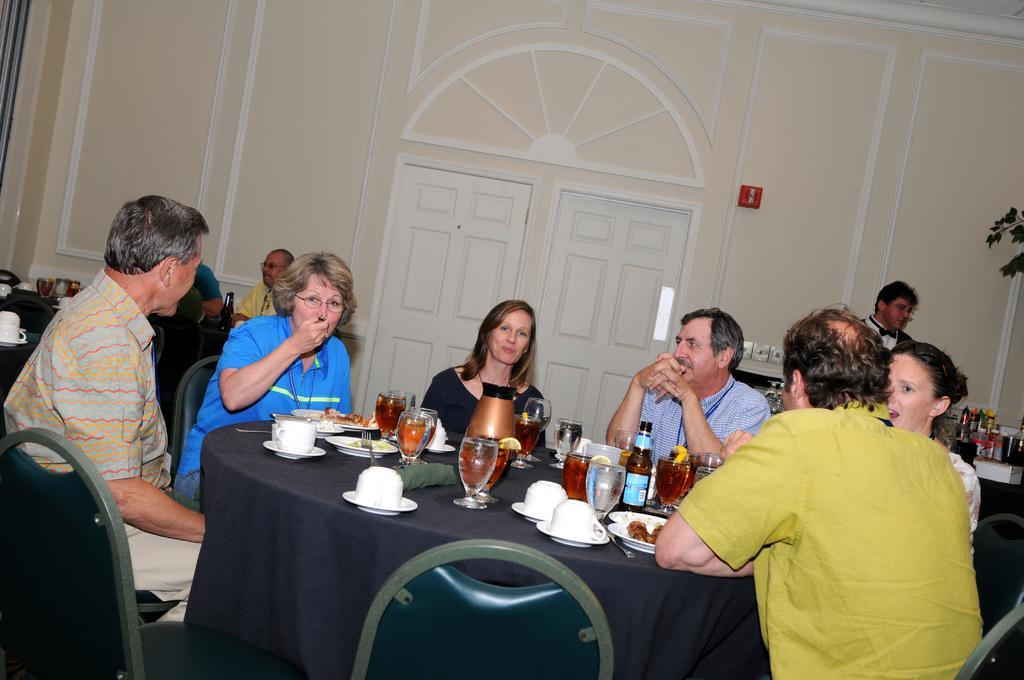Can you describe this image briefly? I think this picture is clicked in a restaurant. There are group of people sitting around a table and having food. On the table there are some glasses, bowls, cup and saucers and a jar. Towards the right there is a table and some jars on it and a plant. In the background there is a door and a wall. 